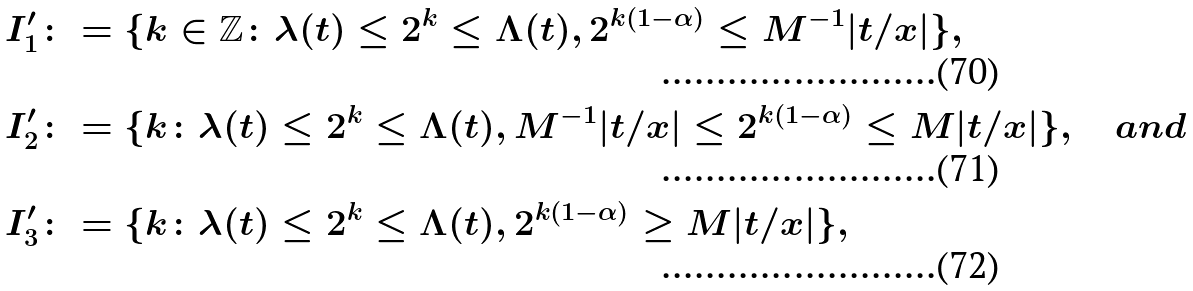<formula> <loc_0><loc_0><loc_500><loc_500>I ^ { \prime } _ { 1 } & \colon = \{ k \in \mathbb { Z } \colon \lambda ( t ) \leq 2 ^ { k } \leq \Lambda ( t ) , 2 ^ { k ( 1 - \alpha ) } \leq M ^ { - 1 } | t / x | \} , \\ I ^ { \prime } _ { 2 } & \colon = \{ k \colon \lambda ( t ) \leq 2 ^ { k } \leq \Lambda ( t ) , M ^ { - 1 } | t / x | \leq 2 ^ { k ( 1 - \alpha ) } \leq M | t / x | \} , \quad a n d \\ I ^ { \prime } _ { 3 } & \colon = \{ k \colon \lambda ( t ) \leq 2 ^ { k } \leq \Lambda ( t ) , 2 ^ { k ( 1 - \alpha ) } \geq M | t / x | \} ,</formula> 